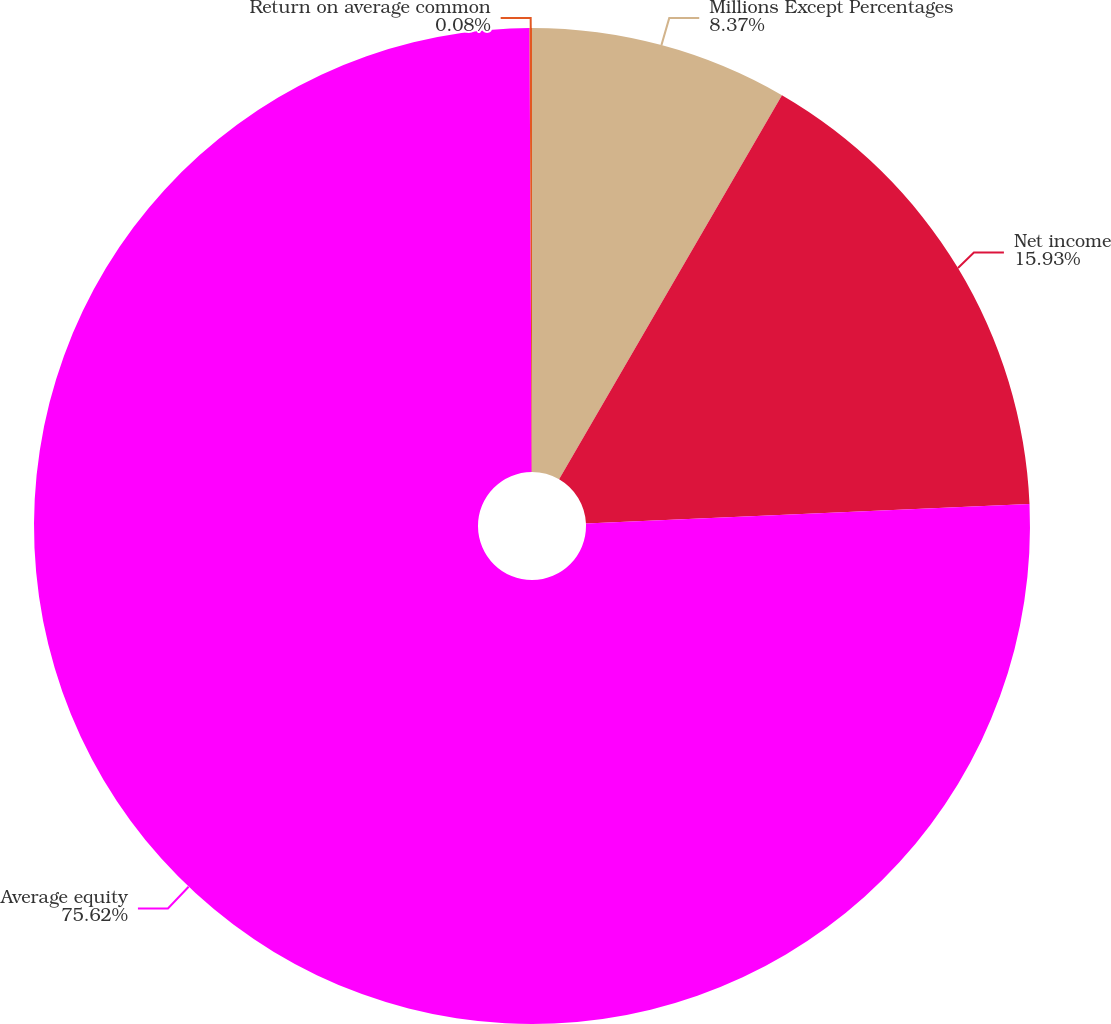Convert chart to OTSL. <chart><loc_0><loc_0><loc_500><loc_500><pie_chart><fcel>Millions Except Percentages<fcel>Net income<fcel>Average equity<fcel>Return on average common<nl><fcel>8.37%<fcel>15.93%<fcel>75.63%<fcel>0.08%<nl></chart> 